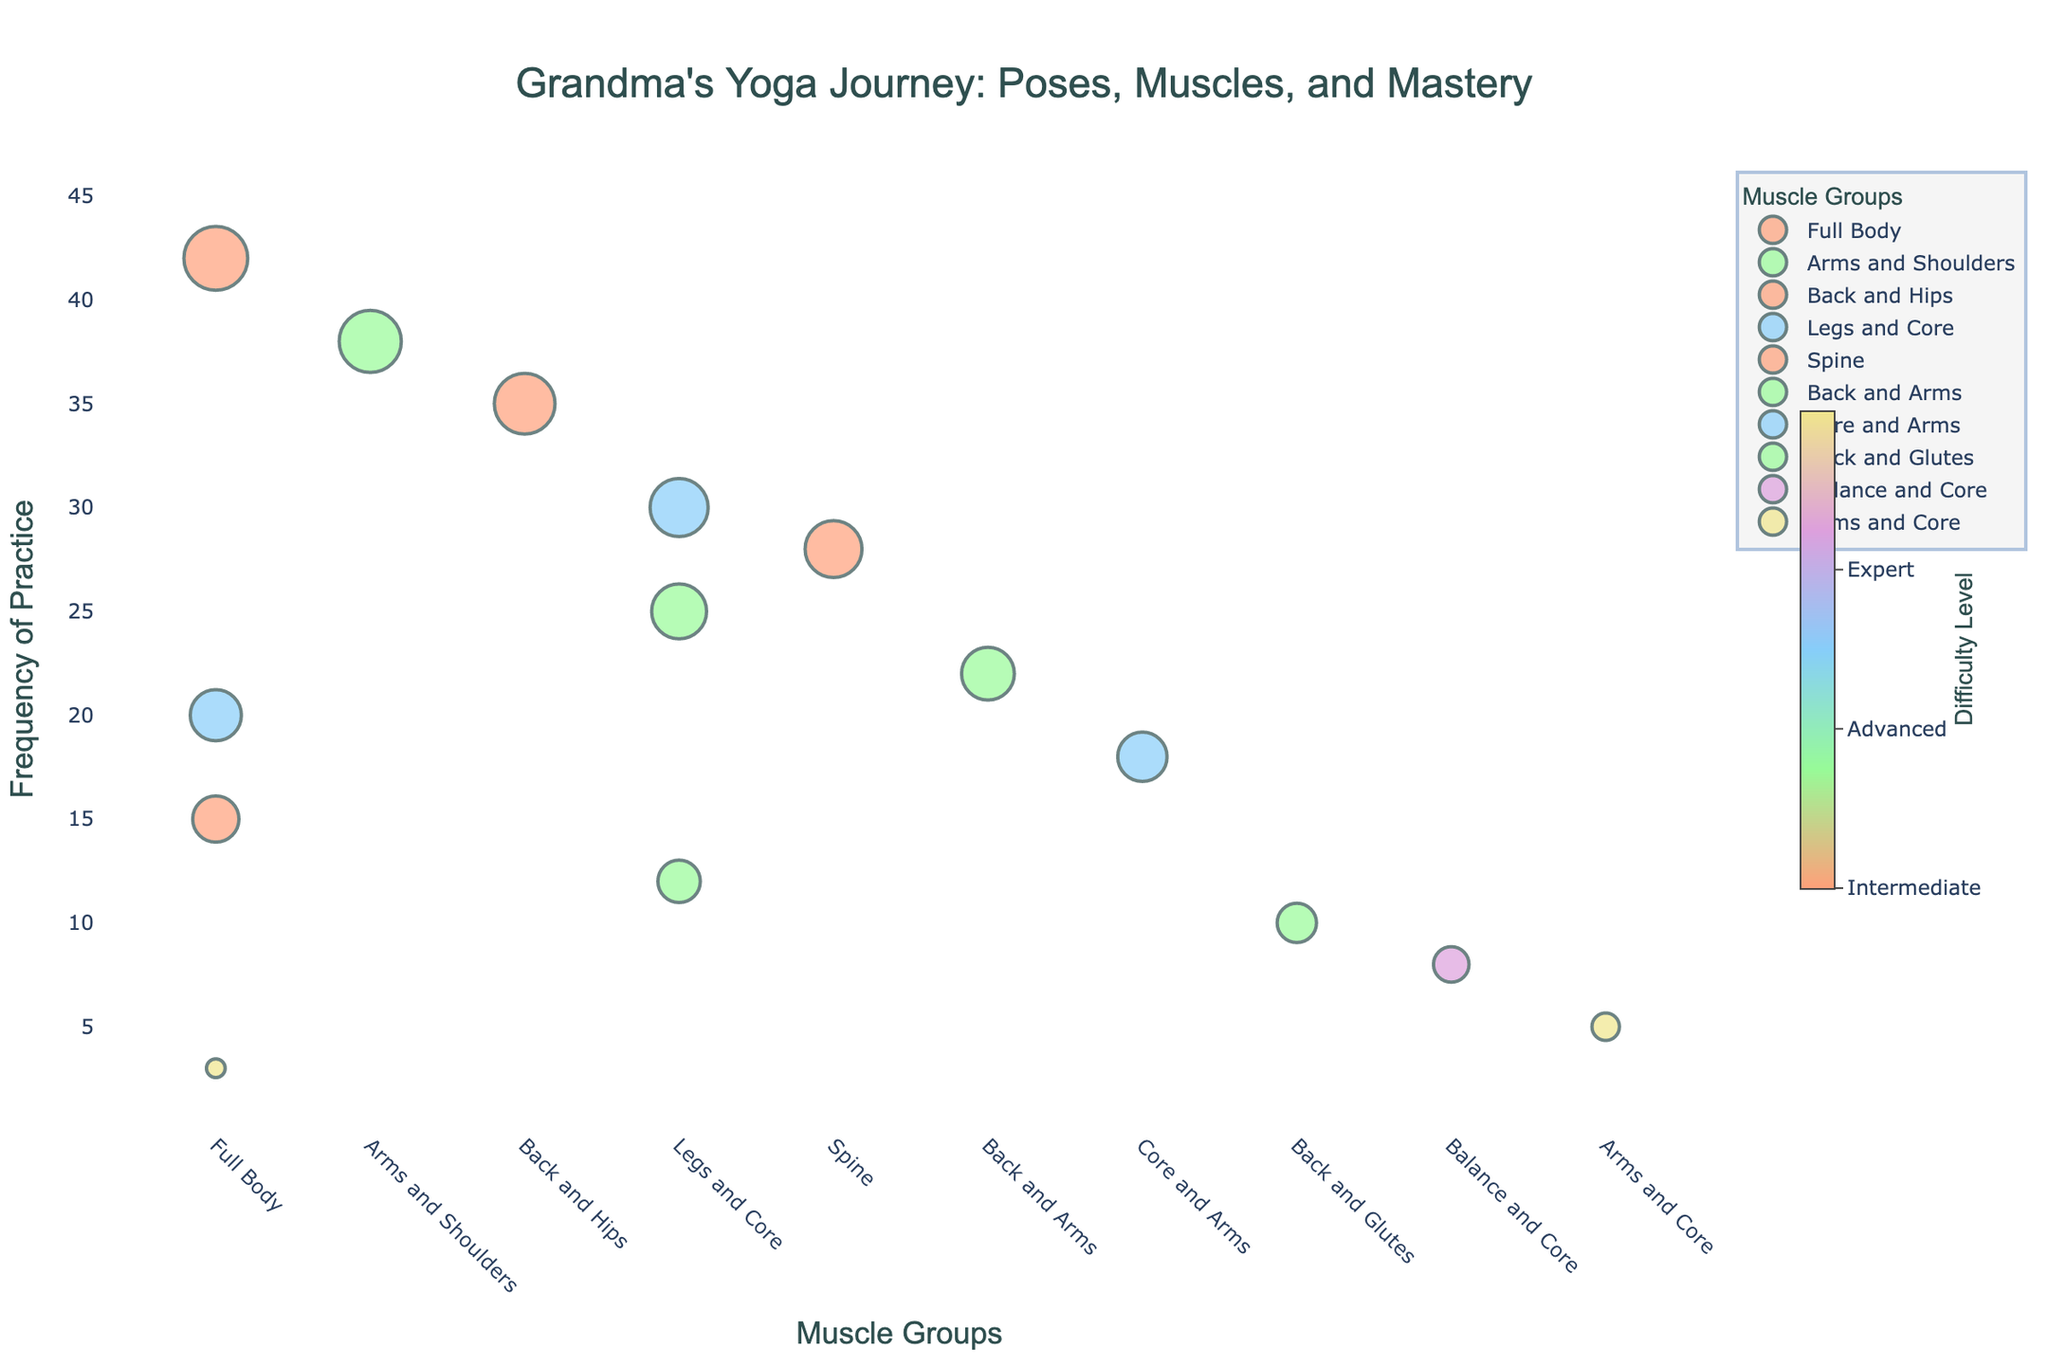What is the title of the plot? The title is typically displayed at the top of the plot and sets the context for what the visualization is about. The plot's title is "Grandma's Yoga Journey: Poses, Muscles, and Mastery," providing insight into how frequently yoga poses are practiced, categorized by muscle groups and difficulty levels.
Answer: Grandma's Yoga Journey: Poses, Muscles, and Mastery What muscle group has the highest number of different poses? To determine which muscle group has the highest number of different poses, look at the unique counts of muscle groups along the x-axis. We see that "Full Body" appears most frequently.
Answer: Full Body Which pose is practiced the most, and which is the least practiced? The vertical axis represents the frequency, and by identifying the highest and the lowest points on this axis, we can see the most practiced pose is "Tadasana" with a frequency of 42, and the least practiced pose is "Headstand" with a frequency of 3.
Answer: Tadasana and Headstand Which pose has the highest difficulty level, and how often is it practiced? The difficulty level is shown through color coding, with the highest difficulty level in a specific color (e.g., 'yellow' for level 5). The pose "Headstand" is in this highest difficulty color and has a frequency of 3.
Answer: Headstand, 3 What is the average frequency of poses in the "Legs and Core" muscle group? To find this, identify all data points under "Legs and Core," sum their frequencies and divide by the number of poses. The frequencies are 30, 25, 12, so (30+25+12)/3 = 67/3 = 22.33.
Answer: 22.33 Compare the practice frequency of the "Full Body" muscle group to the "Arms and Shoulders" muscle group. Which has a higher total frequency? Sum the frequencies of poses in each muscle group: Full Body: 42 + 20 + 15 + 3 = 80; Arms and Shoulders: 38. "Full Body" has a higher total frequency.
Answer: Full Body Which muscle group has poses spanning the widest range of difficulty levels? Check the range of difficulty levels for each muscle group. The "Full Body" group spans from difficulty 1 (Tadasana) to 5 (Headstand).
Answer: Full Body How many poses are considered "Expert" level in difficulty? The color bar explains that the "Expert" level is difficulty level 5, and we identify markers with this color. There are two expert level poses: "Crow Pose" and "Headstand."
Answer: 2 What is the combined frequency of poses with a difficulty level of 2? Identify poses with a difficulty level of 2 and sum their frequencies: Downward Dog (38), Tree Pose (25), Cobra Pose (22), Chair Pose (12), Bridge Pose (10). The combined frequency is 38+25+22+12+10 = 107.
Answer: 107 